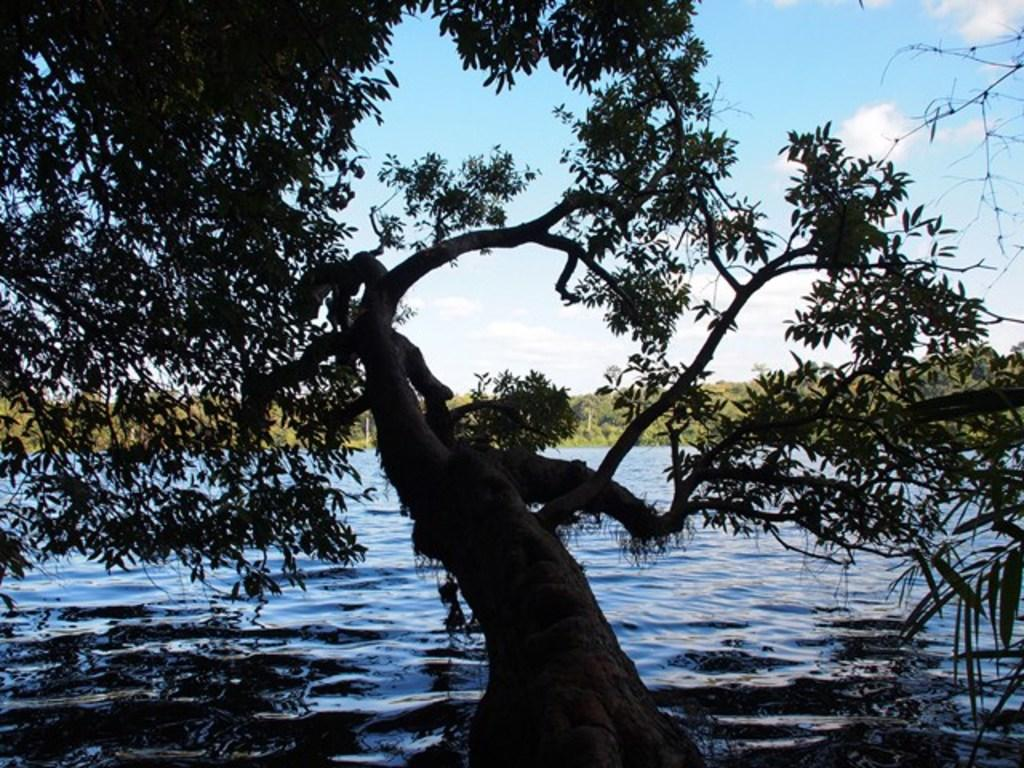What type of vegetation can be seen in the image? There are trees in the image. What part of the trees can be seen in the image? There are leaves in the image. What natural element is visible in the image? Water is visible in the image. What is visible in the background of the image? Trees and the sky are visible in the background of the image. What can be seen in the sky in the image? Clouds are present in the sky. What type of reaction can be seen in the image? There is no reaction visible in the image; it features trees, leaves, water, and a sky with clouds. What type of loss is depicted in the image? There is no loss depicted in the image; it features trees, leaves, water, and a sky with clouds. 